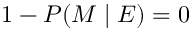<formula> <loc_0><loc_0><loc_500><loc_500>1 - P ( M | E ) = 0</formula> 